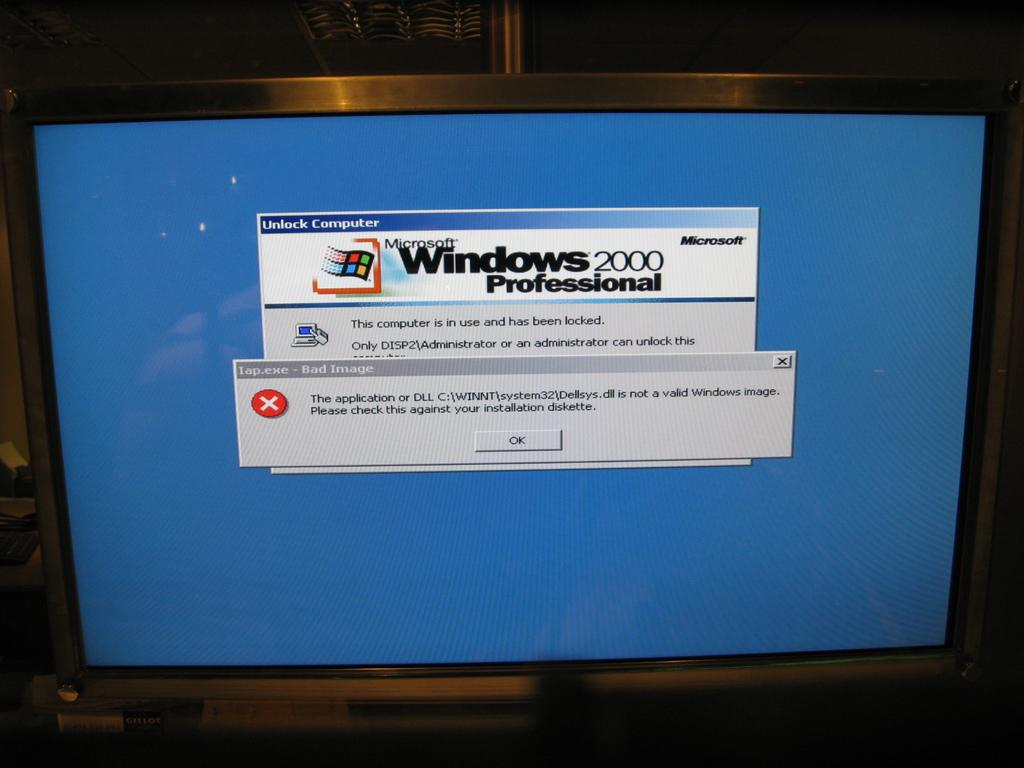<image>
Give a short and clear explanation of the subsequent image. An error message and Windows 2000 professional appear on the blue screen of a computer screen. 